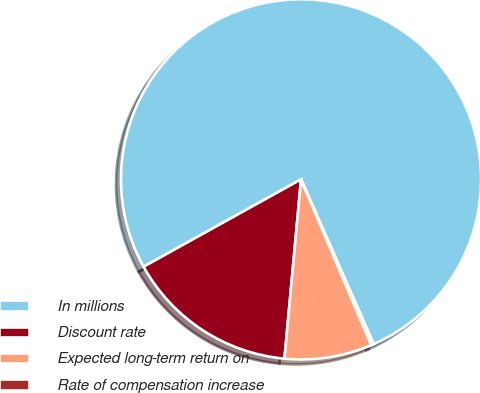Convert chart to OTSL. <chart><loc_0><loc_0><loc_500><loc_500><pie_chart><fcel>In millions<fcel>Discount rate<fcel>Expected long-term return on<fcel>Rate of compensation increase<nl><fcel>76.45%<fcel>15.47%<fcel>7.85%<fcel>0.23%<nl></chart> 